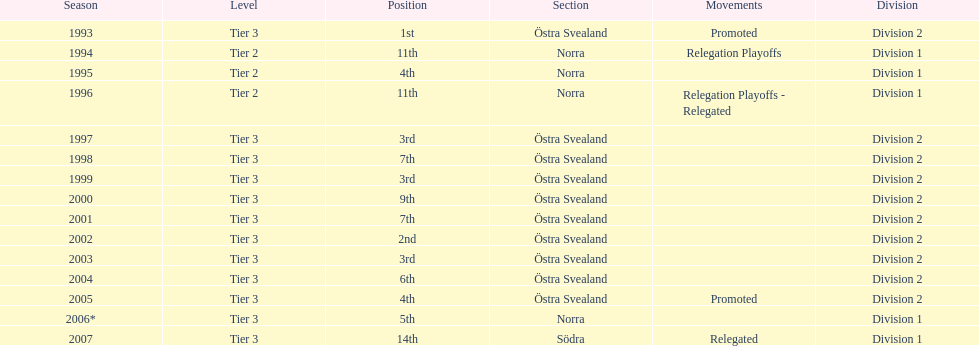In total, how many times were they promoted? 2. 